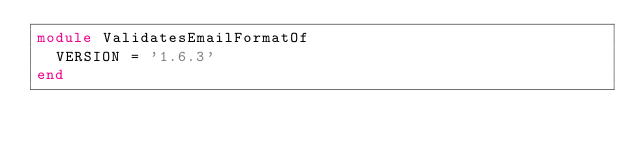Convert code to text. <code><loc_0><loc_0><loc_500><loc_500><_Ruby_>module ValidatesEmailFormatOf
  VERSION = '1.6.3'
end
</code> 